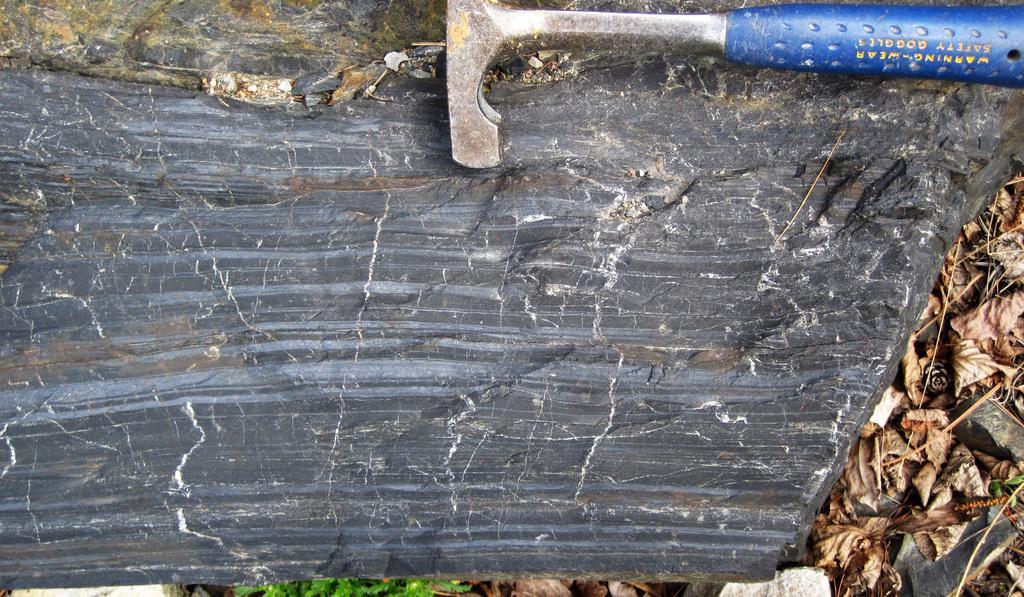How would you summarize this image in a sentence or two? In this image, I can see a hammer on a rock. On the right of the image, there are dried leaves. 